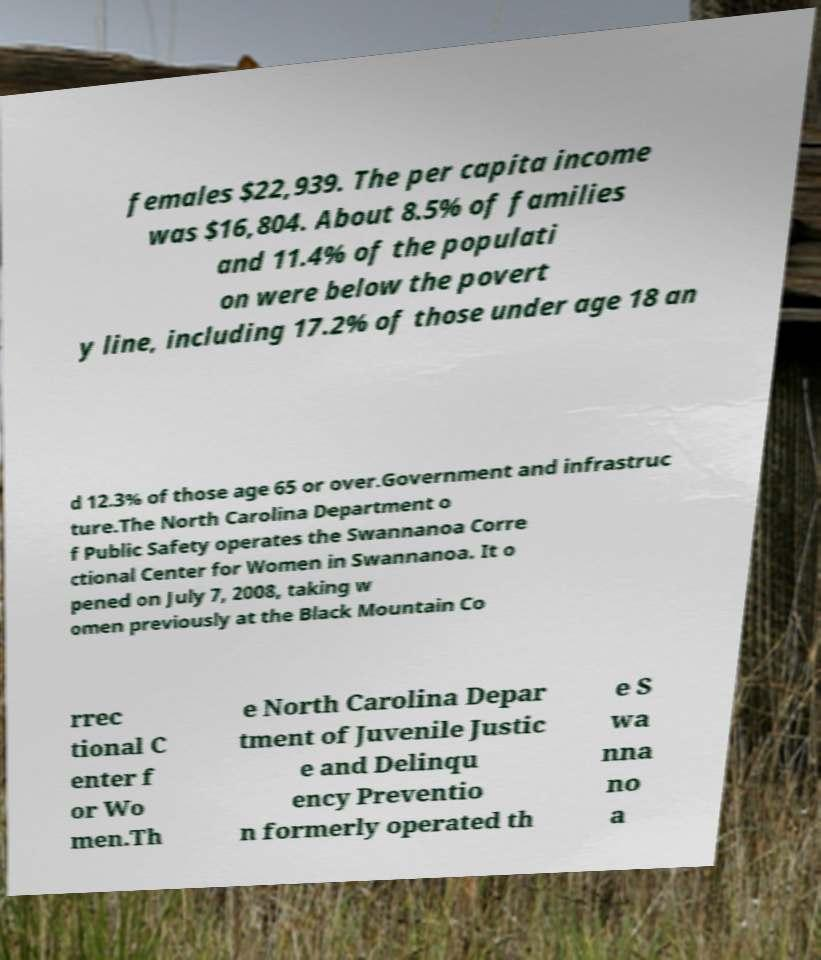Please read and relay the text visible in this image. What does it say? females $22,939. The per capita income was $16,804. About 8.5% of families and 11.4% of the populati on were below the povert y line, including 17.2% of those under age 18 an d 12.3% of those age 65 or over.Government and infrastruc ture.The North Carolina Department o f Public Safety operates the Swannanoa Corre ctional Center for Women in Swannanoa. It o pened on July 7, 2008, taking w omen previously at the Black Mountain Co rrec tional C enter f or Wo men.Th e North Carolina Depar tment of Juvenile Justic e and Delinqu ency Preventio n formerly operated th e S wa nna no a 